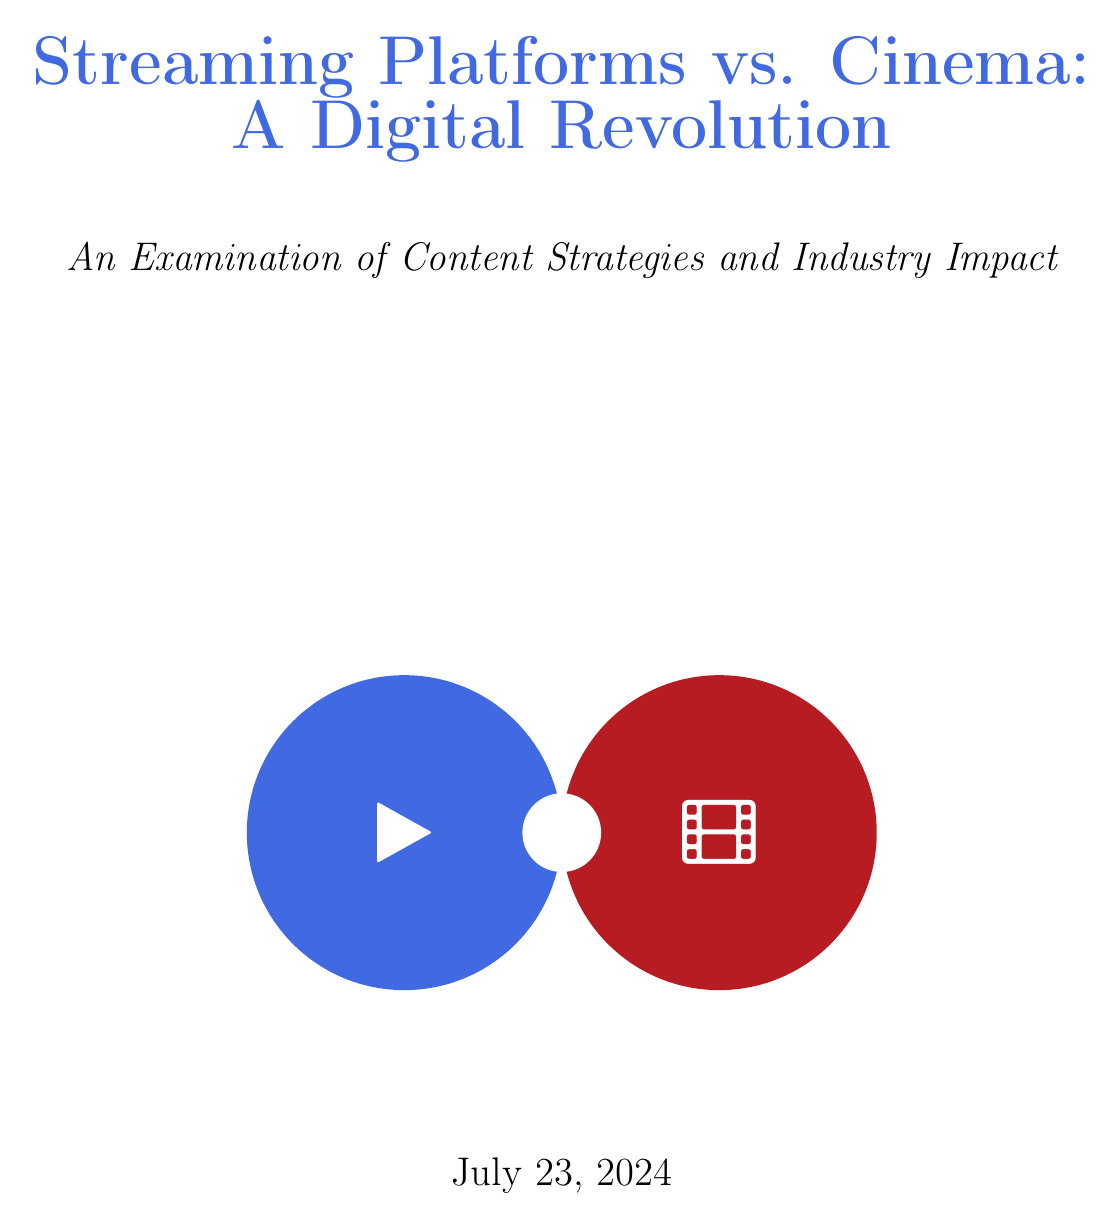What was the global streaming market size in 2020? The document states that the global streaming market size reached $50.11 billion in 2020.
Answer: $50.11 billion What is Netflix's annual content budget for 2021? According to the document, Netflix's annual content budget for 2021 was $17 billion.
Answer: $17 billion What are the notable productions of Amazon Prime Video? The document lists "The Marvelous Mrs. Maisel," "The Boys," and "Manchester by the Sea" as notable productions of Amazon Prime Video.
Answer: The Marvelous Mrs. Maisel, The Boys, Manchester by the Sea What is the current trend in theatrical window changes? The document indicates that the current trend in theatrical windows is 45 days or less, with some day-and-date releases.
Answer: 45 days or less Which filmmakers are pro-streaming? The document mentions Ava DuVernay and Martin Scorsese as pro-streaming filmmakers.
Answer: Ava DuVernay, Martin Scorsese What is the current streaming quality standard? The document specifies that the current standard for streaming quality is 4K HDR.
Answer: 4K HDR What are some rising genres in content trends? According to the document, rising genres include true crime documentaries, Asian dramas, and animated adult series.
Answer: True crime documentaries, Asian dramas, Animated adult series What is a predicted challenge for the future outlook of streaming? The document lists content oversaturation as one of the challenges in the future outlook of streaming.
Answer: Content oversaturation What type of content integration is mentioned as an opportunity? The document states that integration with gaming and interactive media is mentioned as an opportunity.
Answer: Integration with gaming and interactive media 